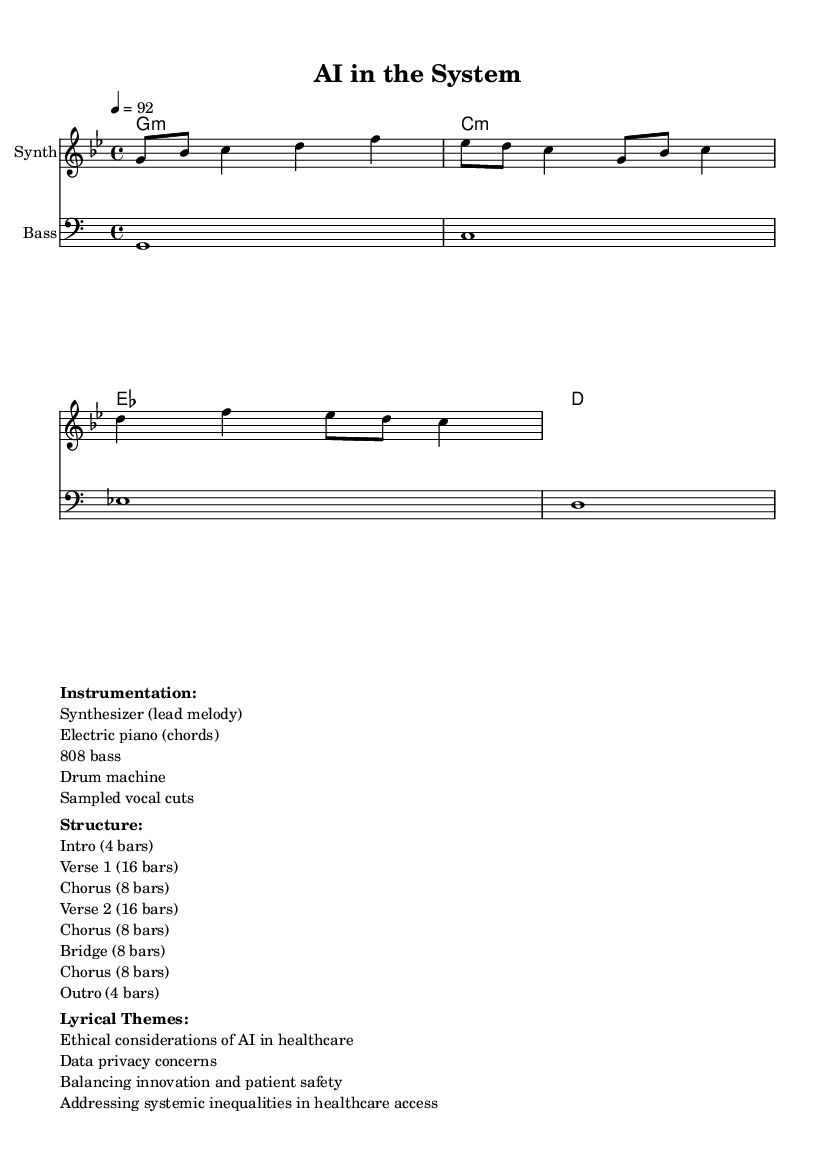What is the key signature of this music? The key signature is indicated by the number of sharps or flats at the beginning of the staff. In this case, it is G minor, which has two flats.
Answer: G minor What is the time signature of this music? The time signature is shown as a fraction indicating beats per measure. Here, it is 4/4, meaning there are four beats in each measure.
Answer: 4/4 What is the tempo marking for this piece? The tempo marking is found at the beginning of the score, specifying the speed of the piece. The marking indicates a speed of 92 beats per minute.
Answer: 92 How many bars are there in the Chorus section? The structure indicates that the Chorus lasts for 8 bars, which can be found in the layout of the song sections.
Answer: 8 bars What is a major lyrical theme present in this song? The lyrical themes are listed under "Lyrical Themes" in the markup section, indicating the main ideas explored in the lyrics. One major theme is the ethical considerations of AI in healthcare.
Answer: Ethical considerations of AI in healthcare What type of bass instrument is used in this piece? The instrumentation section lists the type of instruments used in the piece, and it specifies that the bass is an 808 bass commonly used in Hip Hop.
Answer: 808 bass What is the structure of the first verse? To find the structure of the verse, we refer to the structure marked in the score. The first verse is indicated to be 16 bars long.
Answer: 16 bars 